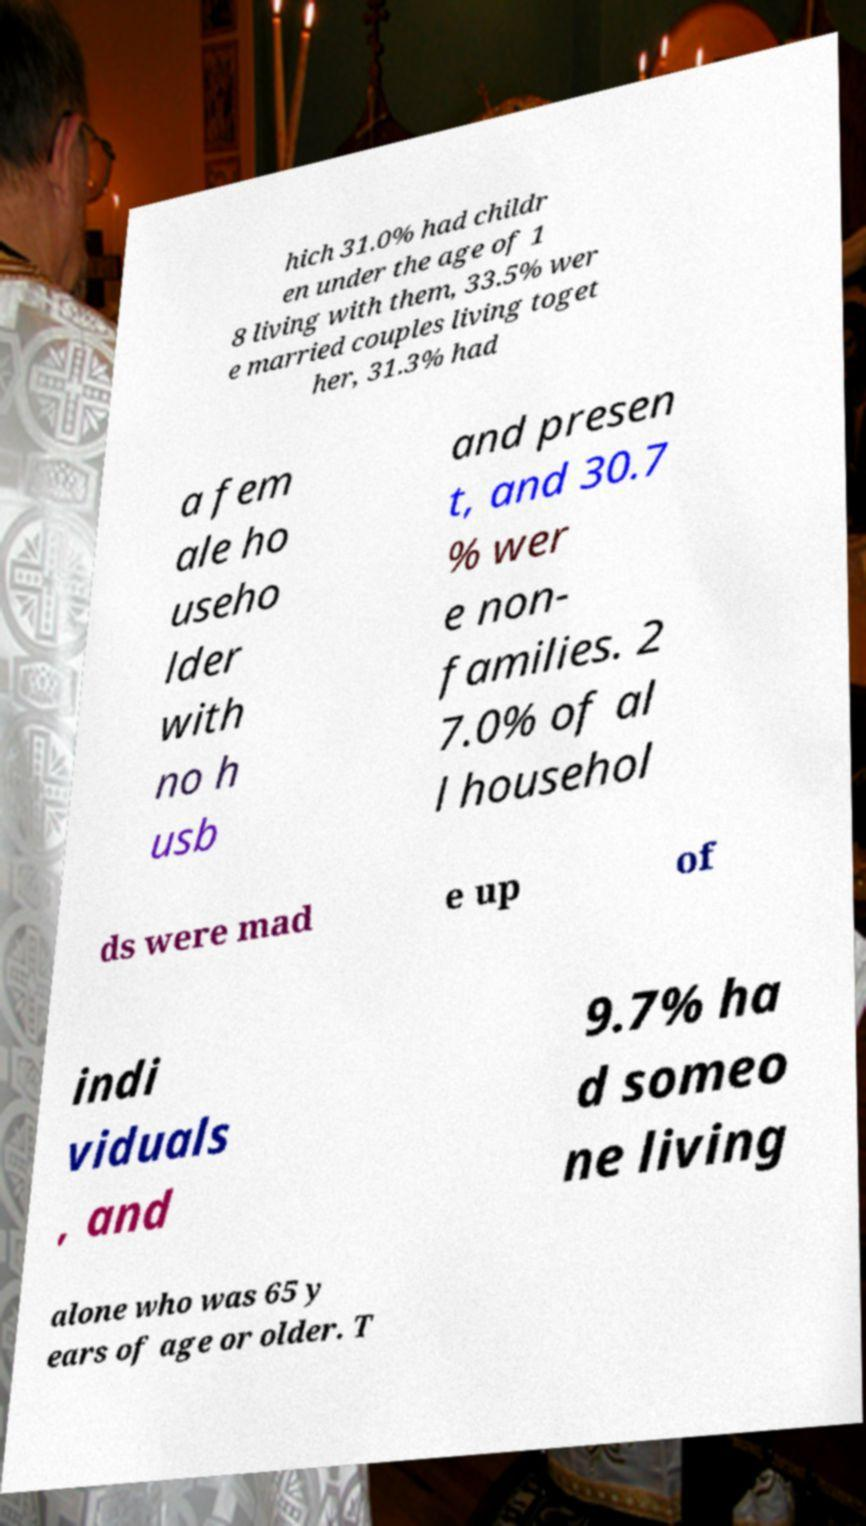Could you assist in decoding the text presented in this image and type it out clearly? hich 31.0% had childr en under the age of 1 8 living with them, 33.5% wer e married couples living toget her, 31.3% had a fem ale ho useho lder with no h usb and presen t, and 30.7 % wer e non- families. 2 7.0% of al l househol ds were mad e up of indi viduals , and 9.7% ha d someo ne living alone who was 65 y ears of age or older. T 